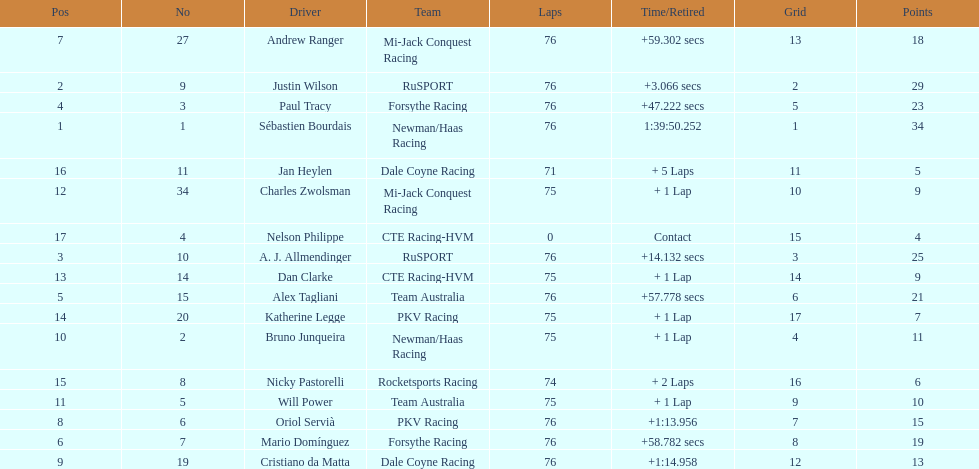Which driver has the least amount of points? Nelson Philippe. 